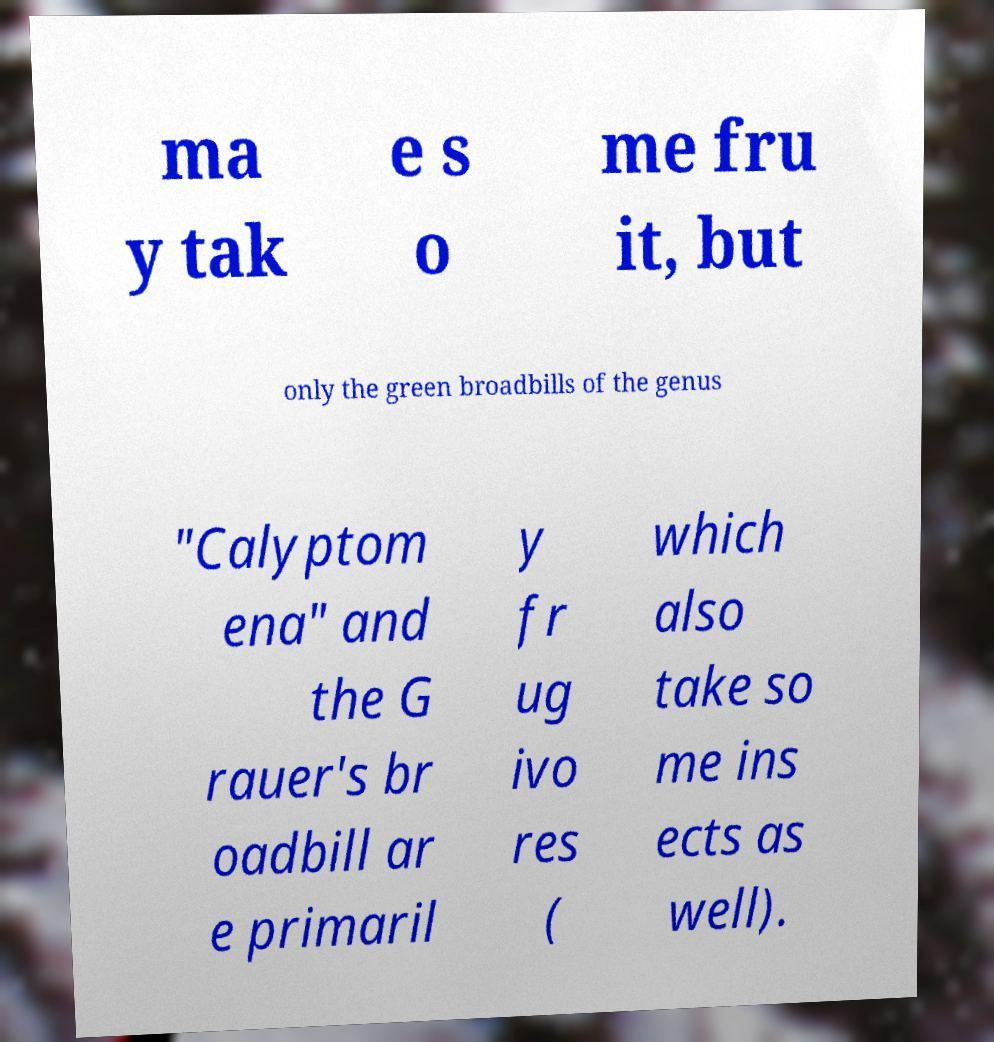Can you accurately transcribe the text from the provided image for me? ma y tak e s o me fru it, but only the green broadbills of the genus "Calyptom ena" and the G rauer's br oadbill ar e primaril y fr ug ivo res ( which also take so me ins ects as well). 